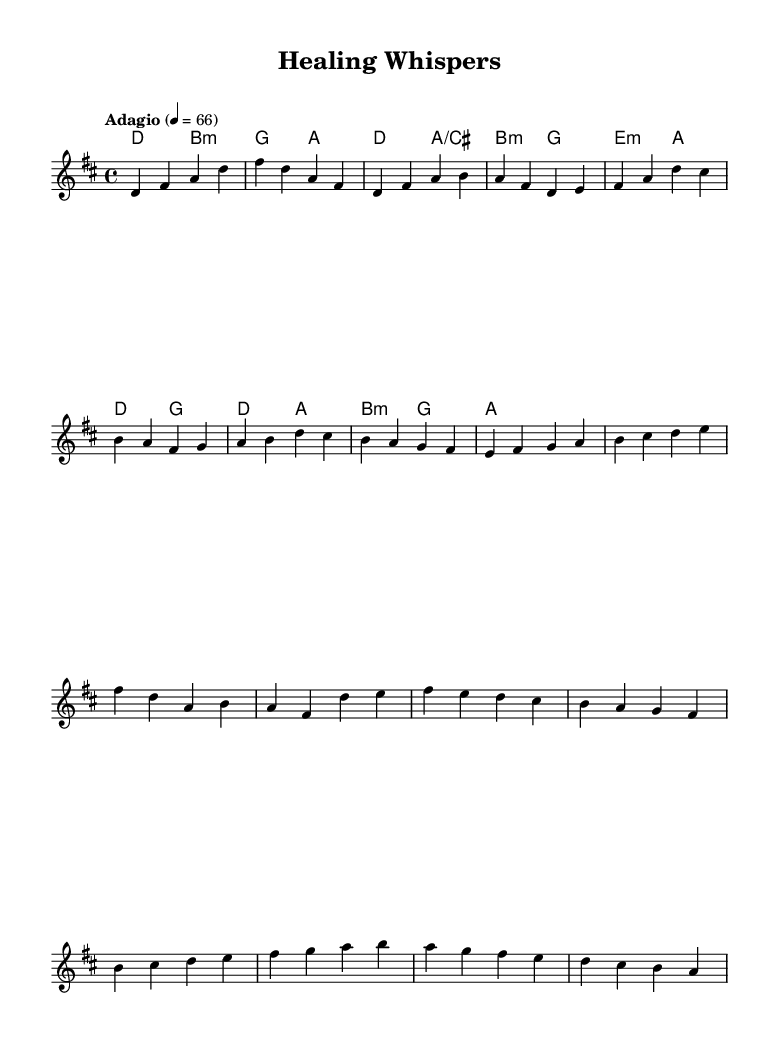What is the key signature of this music? The key signature is D major, which has two sharps (F# and C#). This is determined by looking at the key indicating section in the beginning of the sheet music.
Answer: D major What is the time signature of the piece? The time signature is 4/4, which means there are four beats in a measure, and the quarter note gets one beat. This is evident from the time signature indicated at the beginning of the score.
Answer: 4/4 What tempo marking is indicated for this piece? The tempo marking is "Adagio" at a speed of 66 beats per minute. This can be found in the tempo section at the beginning of the music that specifies the mood and velocity of the piece.
Answer: Adagio How many measures are there in the verse? There are eight measures in the verse, determined by counting the number of groupings marked for the verse section within the sheet music. Each grouping separated by vertical lines corresponds to one measure.
Answer: Eight What is the last note in the melody? The last note in the melody is A. This is found by looking at the final note in the melody line at the end of the score where the music concludes.
Answer: A How many chords are played in the pre-chorus section? There are six chords in the pre-chorus section, as indicated by the chord changes shown in the harmonies section corresponding to that part of the music. The chords are indicated above the melody in each measure.
Answer: Six What type of music structure is used in this piece? This piece utilizes a ballad structure, common in K-Pop, characterized by expressive melodies, emotional themes, and a soothing feel, which is evident from the smooth progression and lyrical style of the melody and harmonies throughout the piece.
Answer: Ballad 